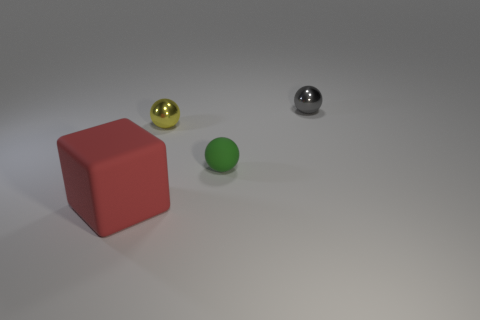Is there anything else that has the same shape as the big matte object?
Offer a terse response. No. Does the large block have the same material as the tiny ball that is on the left side of the green sphere?
Provide a short and direct response. No. What is the material of the tiny sphere that is left of the green sphere?
Offer a terse response. Metal. What is the size of the red rubber block?
Your answer should be very brief. Large. Does the rubber object behind the large red matte cube have the same size as the metal ball left of the gray shiny thing?
Ensure brevity in your answer.  Yes. There is a green ball; is its size the same as the metallic sphere right of the yellow metal ball?
Offer a very short reply. Yes. There is a object that is behind the yellow shiny sphere; is there a tiny green ball that is in front of it?
Your answer should be compact. Yes. There is a matte object that is to the left of the small matte thing; what shape is it?
Your response must be concise. Cube. There is a matte object on the right side of the object to the left of the yellow sphere; what is its color?
Your answer should be very brief. Green. Do the red matte block and the yellow shiny object have the same size?
Provide a short and direct response. No. 